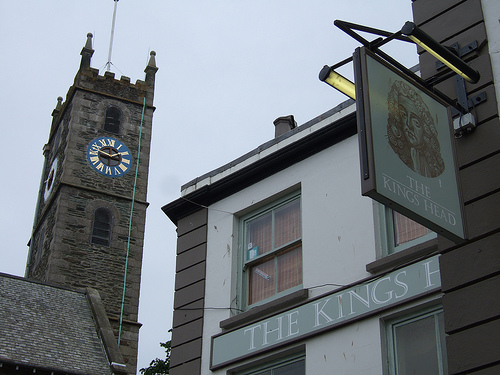Is the large clock on the right side of the picture? No, the large clock is situated on the left side of the picture, located on the tower that rises above the surrounding buildings. 